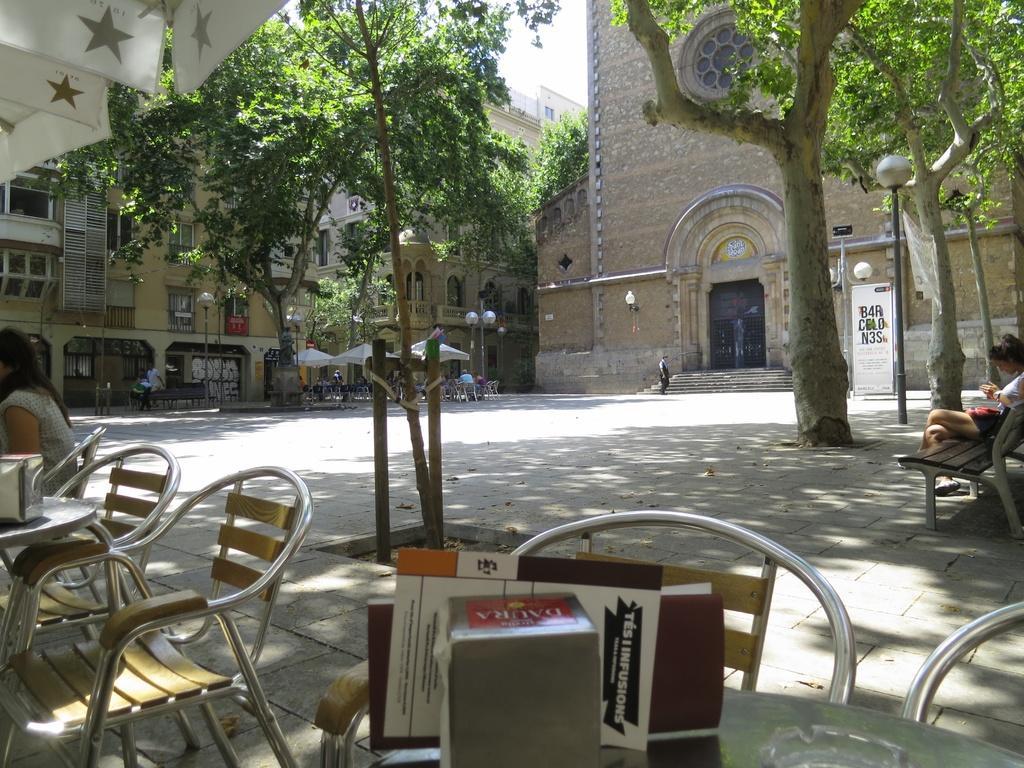Can you describe this image briefly? This is the picture of a place where we have some buildings and around there are some poles which has lamps, chairs, people and some trees. 